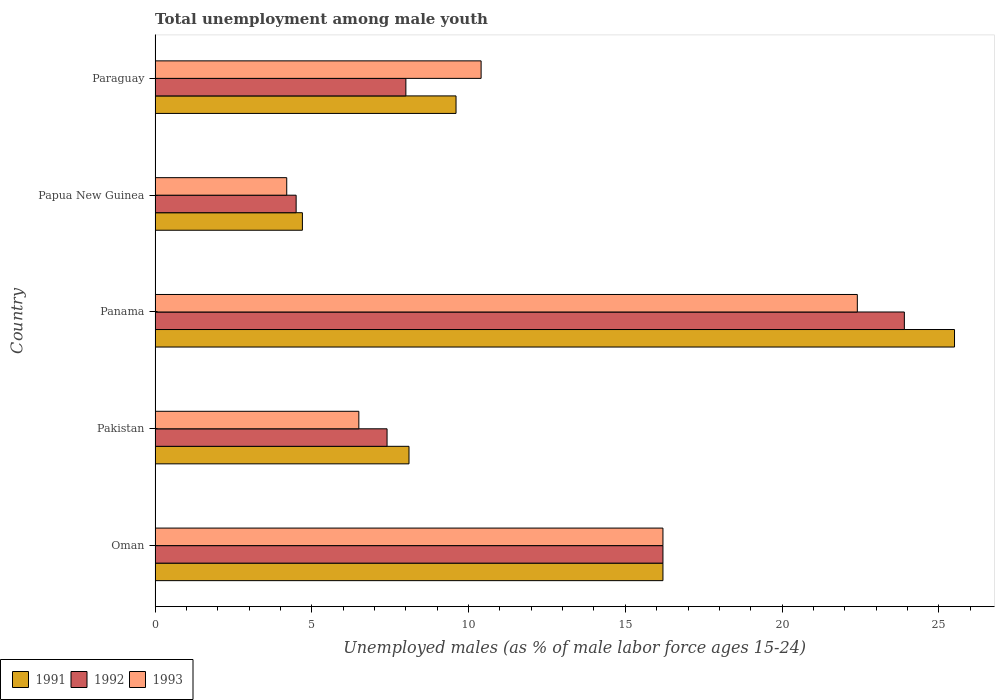How many groups of bars are there?
Your answer should be very brief. 5. Are the number of bars on each tick of the Y-axis equal?
Your response must be concise. Yes. How many bars are there on the 2nd tick from the top?
Offer a very short reply. 3. How many bars are there on the 1st tick from the bottom?
Offer a very short reply. 3. What is the label of the 5th group of bars from the top?
Give a very brief answer. Oman. In how many cases, is the number of bars for a given country not equal to the number of legend labels?
Keep it short and to the point. 0. What is the percentage of unemployed males in in 1991 in Panama?
Ensure brevity in your answer.  25.5. Across all countries, what is the maximum percentage of unemployed males in in 1993?
Provide a succinct answer. 22.4. In which country was the percentage of unemployed males in in 1991 maximum?
Make the answer very short. Panama. In which country was the percentage of unemployed males in in 1992 minimum?
Make the answer very short. Papua New Guinea. What is the total percentage of unemployed males in in 1992 in the graph?
Offer a very short reply. 60. What is the difference between the percentage of unemployed males in in 1991 in Oman and that in Pakistan?
Provide a succinct answer. 8.1. What is the difference between the percentage of unemployed males in in 1992 in Panama and the percentage of unemployed males in in 1991 in Pakistan?
Ensure brevity in your answer.  15.8. What is the average percentage of unemployed males in in 1991 per country?
Ensure brevity in your answer.  12.82. What is the difference between the percentage of unemployed males in in 1991 and percentage of unemployed males in in 1992 in Panama?
Your response must be concise. 1.6. What is the ratio of the percentage of unemployed males in in 1993 in Pakistan to that in Papua New Guinea?
Keep it short and to the point. 1.55. Is the percentage of unemployed males in in 1991 in Papua New Guinea less than that in Paraguay?
Provide a succinct answer. Yes. What is the difference between the highest and the second highest percentage of unemployed males in in 1992?
Offer a very short reply. 7.7. What is the difference between the highest and the lowest percentage of unemployed males in in 1992?
Give a very brief answer. 19.4. In how many countries, is the percentage of unemployed males in in 1991 greater than the average percentage of unemployed males in in 1991 taken over all countries?
Give a very brief answer. 2. Is the sum of the percentage of unemployed males in in 1993 in Papua New Guinea and Paraguay greater than the maximum percentage of unemployed males in in 1991 across all countries?
Offer a terse response. No. What does the 3rd bar from the top in Pakistan represents?
Make the answer very short. 1991. How many bars are there?
Your response must be concise. 15. Are all the bars in the graph horizontal?
Your answer should be very brief. Yes. What is the difference between two consecutive major ticks on the X-axis?
Make the answer very short. 5. Are the values on the major ticks of X-axis written in scientific E-notation?
Offer a terse response. No. Does the graph contain any zero values?
Your response must be concise. No. Where does the legend appear in the graph?
Give a very brief answer. Bottom left. What is the title of the graph?
Your response must be concise. Total unemployment among male youth. What is the label or title of the X-axis?
Make the answer very short. Unemployed males (as % of male labor force ages 15-24). What is the Unemployed males (as % of male labor force ages 15-24) in 1991 in Oman?
Make the answer very short. 16.2. What is the Unemployed males (as % of male labor force ages 15-24) of 1992 in Oman?
Offer a terse response. 16.2. What is the Unemployed males (as % of male labor force ages 15-24) of 1993 in Oman?
Ensure brevity in your answer.  16.2. What is the Unemployed males (as % of male labor force ages 15-24) in 1991 in Pakistan?
Your answer should be compact. 8.1. What is the Unemployed males (as % of male labor force ages 15-24) of 1992 in Pakistan?
Provide a succinct answer. 7.4. What is the Unemployed males (as % of male labor force ages 15-24) of 1993 in Pakistan?
Offer a terse response. 6.5. What is the Unemployed males (as % of male labor force ages 15-24) in 1991 in Panama?
Ensure brevity in your answer.  25.5. What is the Unemployed males (as % of male labor force ages 15-24) of 1992 in Panama?
Your answer should be compact. 23.9. What is the Unemployed males (as % of male labor force ages 15-24) of 1993 in Panama?
Provide a succinct answer. 22.4. What is the Unemployed males (as % of male labor force ages 15-24) in 1991 in Papua New Guinea?
Provide a succinct answer. 4.7. What is the Unemployed males (as % of male labor force ages 15-24) of 1993 in Papua New Guinea?
Ensure brevity in your answer.  4.2. What is the Unemployed males (as % of male labor force ages 15-24) of 1991 in Paraguay?
Provide a short and direct response. 9.6. What is the Unemployed males (as % of male labor force ages 15-24) in 1993 in Paraguay?
Provide a succinct answer. 10.4. Across all countries, what is the maximum Unemployed males (as % of male labor force ages 15-24) in 1992?
Your response must be concise. 23.9. Across all countries, what is the maximum Unemployed males (as % of male labor force ages 15-24) in 1993?
Your answer should be compact. 22.4. Across all countries, what is the minimum Unemployed males (as % of male labor force ages 15-24) of 1991?
Provide a short and direct response. 4.7. Across all countries, what is the minimum Unemployed males (as % of male labor force ages 15-24) of 1992?
Your response must be concise. 4.5. Across all countries, what is the minimum Unemployed males (as % of male labor force ages 15-24) in 1993?
Your answer should be compact. 4.2. What is the total Unemployed males (as % of male labor force ages 15-24) in 1991 in the graph?
Your answer should be compact. 64.1. What is the total Unemployed males (as % of male labor force ages 15-24) of 1993 in the graph?
Your answer should be very brief. 59.7. What is the difference between the Unemployed males (as % of male labor force ages 15-24) in 1992 in Oman and that in Pakistan?
Your answer should be compact. 8.8. What is the difference between the Unemployed males (as % of male labor force ages 15-24) in 1991 in Oman and that in Panama?
Provide a short and direct response. -9.3. What is the difference between the Unemployed males (as % of male labor force ages 15-24) of 1992 in Oman and that in Papua New Guinea?
Your answer should be very brief. 11.7. What is the difference between the Unemployed males (as % of male labor force ages 15-24) in 1992 in Oman and that in Paraguay?
Keep it short and to the point. 8.2. What is the difference between the Unemployed males (as % of male labor force ages 15-24) of 1991 in Pakistan and that in Panama?
Offer a terse response. -17.4. What is the difference between the Unemployed males (as % of male labor force ages 15-24) in 1992 in Pakistan and that in Panama?
Ensure brevity in your answer.  -16.5. What is the difference between the Unemployed males (as % of male labor force ages 15-24) in 1993 in Pakistan and that in Panama?
Give a very brief answer. -15.9. What is the difference between the Unemployed males (as % of male labor force ages 15-24) in 1993 in Pakistan and that in Papua New Guinea?
Provide a short and direct response. 2.3. What is the difference between the Unemployed males (as % of male labor force ages 15-24) in 1991 in Pakistan and that in Paraguay?
Offer a terse response. -1.5. What is the difference between the Unemployed males (as % of male labor force ages 15-24) of 1991 in Panama and that in Papua New Guinea?
Provide a succinct answer. 20.8. What is the difference between the Unemployed males (as % of male labor force ages 15-24) of 1992 in Panama and that in Papua New Guinea?
Provide a succinct answer. 19.4. What is the difference between the Unemployed males (as % of male labor force ages 15-24) in 1993 in Panama and that in Papua New Guinea?
Keep it short and to the point. 18.2. What is the difference between the Unemployed males (as % of male labor force ages 15-24) in 1991 in Panama and that in Paraguay?
Offer a terse response. 15.9. What is the difference between the Unemployed males (as % of male labor force ages 15-24) of 1992 in Panama and that in Paraguay?
Your answer should be very brief. 15.9. What is the difference between the Unemployed males (as % of male labor force ages 15-24) in 1992 in Papua New Guinea and that in Paraguay?
Keep it short and to the point. -3.5. What is the difference between the Unemployed males (as % of male labor force ages 15-24) in 1993 in Papua New Guinea and that in Paraguay?
Ensure brevity in your answer.  -6.2. What is the difference between the Unemployed males (as % of male labor force ages 15-24) of 1991 in Oman and the Unemployed males (as % of male labor force ages 15-24) of 1992 in Pakistan?
Offer a very short reply. 8.8. What is the difference between the Unemployed males (as % of male labor force ages 15-24) of 1991 in Oman and the Unemployed males (as % of male labor force ages 15-24) of 1993 in Pakistan?
Keep it short and to the point. 9.7. What is the difference between the Unemployed males (as % of male labor force ages 15-24) in 1992 in Oman and the Unemployed males (as % of male labor force ages 15-24) in 1993 in Pakistan?
Provide a short and direct response. 9.7. What is the difference between the Unemployed males (as % of male labor force ages 15-24) in 1991 in Oman and the Unemployed males (as % of male labor force ages 15-24) in 1993 in Panama?
Your answer should be very brief. -6.2. What is the difference between the Unemployed males (as % of male labor force ages 15-24) of 1992 in Oman and the Unemployed males (as % of male labor force ages 15-24) of 1993 in Panama?
Offer a terse response. -6.2. What is the difference between the Unemployed males (as % of male labor force ages 15-24) of 1991 in Oman and the Unemployed males (as % of male labor force ages 15-24) of 1992 in Papua New Guinea?
Your answer should be very brief. 11.7. What is the difference between the Unemployed males (as % of male labor force ages 15-24) in 1991 in Oman and the Unemployed males (as % of male labor force ages 15-24) in 1992 in Paraguay?
Your response must be concise. 8.2. What is the difference between the Unemployed males (as % of male labor force ages 15-24) of 1991 in Oman and the Unemployed males (as % of male labor force ages 15-24) of 1993 in Paraguay?
Ensure brevity in your answer.  5.8. What is the difference between the Unemployed males (as % of male labor force ages 15-24) of 1992 in Oman and the Unemployed males (as % of male labor force ages 15-24) of 1993 in Paraguay?
Your answer should be compact. 5.8. What is the difference between the Unemployed males (as % of male labor force ages 15-24) of 1991 in Pakistan and the Unemployed males (as % of male labor force ages 15-24) of 1992 in Panama?
Offer a terse response. -15.8. What is the difference between the Unemployed males (as % of male labor force ages 15-24) in 1991 in Pakistan and the Unemployed males (as % of male labor force ages 15-24) in 1993 in Panama?
Make the answer very short. -14.3. What is the difference between the Unemployed males (as % of male labor force ages 15-24) in 1992 in Pakistan and the Unemployed males (as % of male labor force ages 15-24) in 1993 in Panama?
Ensure brevity in your answer.  -15. What is the difference between the Unemployed males (as % of male labor force ages 15-24) of 1991 in Pakistan and the Unemployed males (as % of male labor force ages 15-24) of 1992 in Papua New Guinea?
Offer a terse response. 3.6. What is the difference between the Unemployed males (as % of male labor force ages 15-24) of 1991 in Pakistan and the Unemployed males (as % of male labor force ages 15-24) of 1993 in Papua New Guinea?
Offer a terse response. 3.9. What is the difference between the Unemployed males (as % of male labor force ages 15-24) of 1992 in Pakistan and the Unemployed males (as % of male labor force ages 15-24) of 1993 in Papua New Guinea?
Your response must be concise. 3.2. What is the difference between the Unemployed males (as % of male labor force ages 15-24) of 1991 in Pakistan and the Unemployed males (as % of male labor force ages 15-24) of 1993 in Paraguay?
Make the answer very short. -2.3. What is the difference between the Unemployed males (as % of male labor force ages 15-24) in 1992 in Pakistan and the Unemployed males (as % of male labor force ages 15-24) in 1993 in Paraguay?
Give a very brief answer. -3. What is the difference between the Unemployed males (as % of male labor force ages 15-24) of 1991 in Panama and the Unemployed males (as % of male labor force ages 15-24) of 1992 in Papua New Guinea?
Give a very brief answer. 21. What is the difference between the Unemployed males (as % of male labor force ages 15-24) of 1991 in Panama and the Unemployed males (as % of male labor force ages 15-24) of 1993 in Papua New Guinea?
Offer a terse response. 21.3. What is the difference between the Unemployed males (as % of male labor force ages 15-24) in 1992 in Panama and the Unemployed males (as % of male labor force ages 15-24) in 1993 in Papua New Guinea?
Make the answer very short. 19.7. What is the difference between the Unemployed males (as % of male labor force ages 15-24) of 1991 in Panama and the Unemployed males (as % of male labor force ages 15-24) of 1992 in Paraguay?
Keep it short and to the point. 17.5. What is the difference between the Unemployed males (as % of male labor force ages 15-24) in 1991 in Papua New Guinea and the Unemployed males (as % of male labor force ages 15-24) in 1993 in Paraguay?
Offer a very short reply. -5.7. What is the average Unemployed males (as % of male labor force ages 15-24) in 1991 per country?
Make the answer very short. 12.82. What is the average Unemployed males (as % of male labor force ages 15-24) in 1992 per country?
Your answer should be compact. 12. What is the average Unemployed males (as % of male labor force ages 15-24) of 1993 per country?
Make the answer very short. 11.94. What is the difference between the Unemployed males (as % of male labor force ages 15-24) of 1992 and Unemployed males (as % of male labor force ages 15-24) of 1993 in Oman?
Your answer should be very brief. 0. What is the difference between the Unemployed males (as % of male labor force ages 15-24) in 1991 and Unemployed males (as % of male labor force ages 15-24) in 1992 in Pakistan?
Your answer should be compact. 0.7. What is the difference between the Unemployed males (as % of male labor force ages 15-24) of 1991 and Unemployed males (as % of male labor force ages 15-24) of 1993 in Pakistan?
Your response must be concise. 1.6. What is the difference between the Unemployed males (as % of male labor force ages 15-24) of 1991 and Unemployed males (as % of male labor force ages 15-24) of 1992 in Panama?
Offer a terse response. 1.6. What is the difference between the Unemployed males (as % of male labor force ages 15-24) in 1991 and Unemployed males (as % of male labor force ages 15-24) in 1993 in Panama?
Your response must be concise. 3.1. What is the difference between the Unemployed males (as % of male labor force ages 15-24) of 1992 and Unemployed males (as % of male labor force ages 15-24) of 1993 in Panama?
Offer a terse response. 1.5. What is the difference between the Unemployed males (as % of male labor force ages 15-24) in 1991 and Unemployed males (as % of male labor force ages 15-24) in 1992 in Papua New Guinea?
Offer a terse response. 0.2. What is the difference between the Unemployed males (as % of male labor force ages 15-24) of 1992 and Unemployed males (as % of male labor force ages 15-24) of 1993 in Papua New Guinea?
Offer a very short reply. 0.3. What is the ratio of the Unemployed males (as % of male labor force ages 15-24) of 1991 in Oman to that in Pakistan?
Give a very brief answer. 2. What is the ratio of the Unemployed males (as % of male labor force ages 15-24) of 1992 in Oman to that in Pakistan?
Make the answer very short. 2.19. What is the ratio of the Unemployed males (as % of male labor force ages 15-24) in 1993 in Oman to that in Pakistan?
Your answer should be very brief. 2.49. What is the ratio of the Unemployed males (as % of male labor force ages 15-24) of 1991 in Oman to that in Panama?
Give a very brief answer. 0.64. What is the ratio of the Unemployed males (as % of male labor force ages 15-24) in 1992 in Oman to that in Panama?
Give a very brief answer. 0.68. What is the ratio of the Unemployed males (as % of male labor force ages 15-24) in 1993 in Oman to that in Panama?
Ensure brevity in your answer.  0.72. What is the ratio of the Unemployed males (as % of male labor force ages 15-24) of 1991 in Oman to that in Papua New Guinea?
Offer a very short reply. 3.45. What is the ratio of the Unemployed males (as % of male labor force ages 15-24) in 1992 in Oman to that in Papua New Guinea?
Your answer should be compact. 3.6. What is the ratio of the Unemployed males (as % of male labor force ages 15-24) in 1993 in Oman to that in Papua New Guinea?
Your answer should be compact. 3.86. What is the ratio of the Unemployed males (as % of male labor force ages 15-24) of 1991 in Oman to that in Paraguay?
Offer a terse response. 1.69. What is the ratio of the Unemployed males (as % of male labor force ages 15-24) in 1992 in Oman to that in Paraguay?
Provide a succinct answer. 2.02. What is the ratio of the Unemployed males (as % of male labor force ages 15-24) of 1993 in Oman to that in Paraguay?
Offer a terse response. 1.56. What is the ratio of the Unemployed males (as % of male labor force ages 15-24) in 1991 in Pakistan to that in Panama?
Make the answer very short. 0.32. What is the ratio of the Unemployed males (as % of male labor force ages 15-24) in 1992 in Pakistan to that in Panama?
Make the answer very short. 0.31. What is the ratio of the Unemployed males (as % of male labor force ages 15-24) of 1993 in Pakistan to that in Panama?
Ensure brevity in your answer.  0.29. What is the ratio of the Unemployed males (as % of male labor force ages 15-24) in 1991 in Pakistan to that in Papua New Guinea?
Your answer should be compact. 1.72. What is the ratio of the Unemployed males (as % of male labor force ages 15-24) in 1992 in Pakistan to that in Papua New Guinea?
Provide a short and direct response. 1.64. What is the ratio of the Unemployed males (as % of male labor force ages 15-24) in 1993 in Pakistan to that in Papua New Guinea?
Offer a terse response. 1.55. What is the ratio of the Unemployed males (as % of male labor force ages 15-24) in 1991 in Pakistan to that in Paraguay?
Ensure brevity in your answer.  0.84. What is the ratio of the Unemployed males (as % of male labor force ages 15-24) of 1992 in Pakistan to that in Paraguay?
Provide a succinct answer. 0.93. What is the ratio of the Unemployed males (as % of male labor force ages 15-24) of 1991 in Panama to that in Papua New Guinea?
Keep it short and to the point. 5.43. What is the ratio of the Unemployed males (as % of male labor force ages 15-24) in 1992 in Panama to that in Papua New Guinea?
Provide a succinct answer. 5.31. What is the ratio of the Unemployed males (as % of male labor force ages 15-24) in 1993 in Panama to that in Papua New Guinea?
Provide a short and direct response. 5.33. What is the ratio of the Unemployed males (as % of male labor force ages 15-24) of 1991 in Panama to that in Paraguay?
Make the answer very short. 2.66. What is the ratio of the Unemployed males (as % of male labor force ages 15-24) of 1992 in Panama to that in Paraguay?
Provide a succinct answer. 2.99. What is the ratio of the Unemployed males (as % of male labor force ages 15-24) of 1993 in Panama to that in Paraguay?
Offer a very short reply. 2.15. What is the ratio of the Unemployed males (as % of male labor force ages 15-24) in 1991 in Papua New Guinea to that in Paraguay?
Make the answer very short. 0.49. What is the ratio of the Unemployed males (as % of male labor force ages 15-24) of 1992 in Papua New Guinea to that in Paraguay?
Give a very brief answer. 0.56. What is the ratio of the Unemployed males (as % of male labor force ages 15-24) in 1993 in Papua New Guinea to that in Paraguay?
Provide a succinct answer. 0.4. What is the difference between the highest and the second highest Unemployed males (as % of male labor force ages 15-24) of 1991?
Your answer should be very brief. 9.3. What is the difference between the highest and the second highest Unemployed males (as % of male labor force ages 15-24) in 1993?
Offer a very short reply. 6.2. What is the difference between the highest and the lowest Unemployed males (as % of male labor force ages 15-24) of 1991?
Ensure brevity in your answer.  20.8. What is the difference between the highest and the lowest Unemployed males (as % of male labor force ages 15-24) in 1992?
Your answer should be very brief. 19.4. What is the difference between the highest and the lowest Unemployed males (as % of male labor force ages 15-24) of 1993?
Your response must be concise. 18.2. 